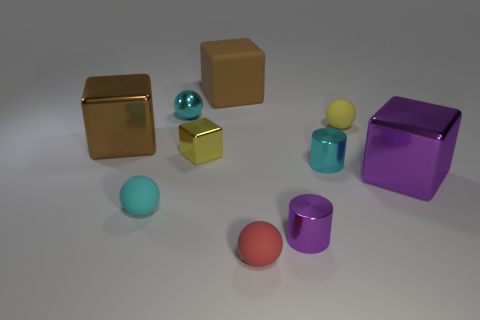What shape is the small cyan object that is both to the right of the cyan rubber object and in front of the small yellow matte sphere?
Offer a very short reply. Cylinder. How big is the brown cube that is on the right side of the cyan shiny thing left of the tiny cube?
Offer a very short reply. Large. What number of metal things have the same color as the large rubber block?
Make the answer very short. 1. What number of other things are there of the same size as the cyan shiny sphere?
Your response must be concise. 6. What size is the object that is both to the right of the cyan cylinder and to the left of the purple shiny cube?
Your answer should be very brief. Small. How many cyan objects are the same shape as the yellow metallic thing?
Offer a very short reply. 0. What material is the small yellow ball?
Give a very brief answer. Rubber. Do the brown rubber thing and the large purple metal thing have the same shape?
Offer a very short reply. Yes. Is there a big purple block made of the same material as the red thing?
Keep it short and to the point. No. There is a object that is behind the tiny metallic cube and to the right of the red matte thing; what is its color?
Your answer should be very brief. Yellow. 